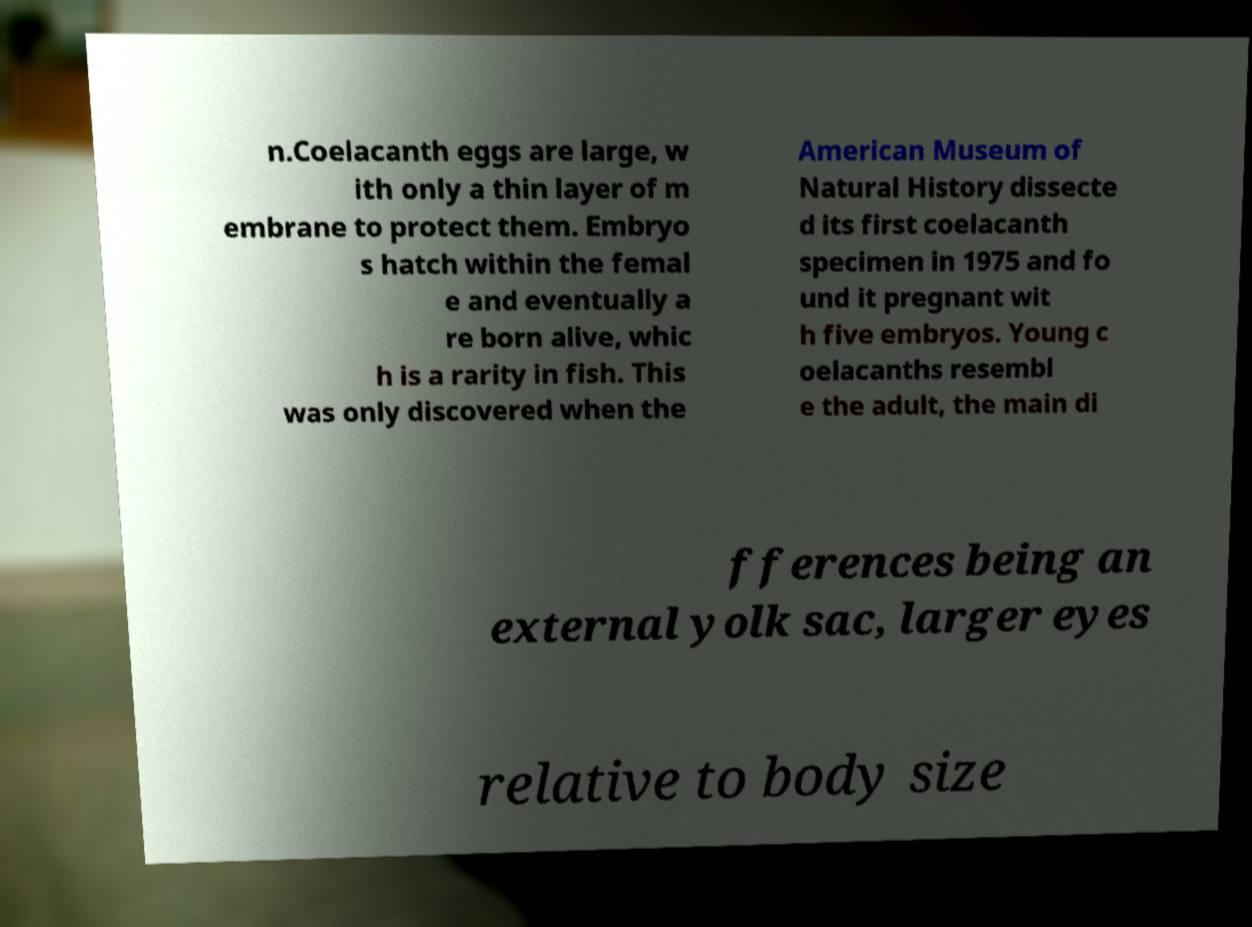What messages or text are displayed in this image? I need them in a readable, typed format. n.Coelacanth eggs are large, w ith only a thin layer of m embrane to protect them. Embryo s hatch within the femal e and eventually a re born alive, whic h is a rarity in fish. This was only discovered when the American Museum of Natural History dissecte d its first coelacanth specimen in 1975 and fo und it pregnant wit h five embryos. Young c oelacanths resembl e the adult, the main di fferences being an external yolk sac, larger eyes relative to body size 